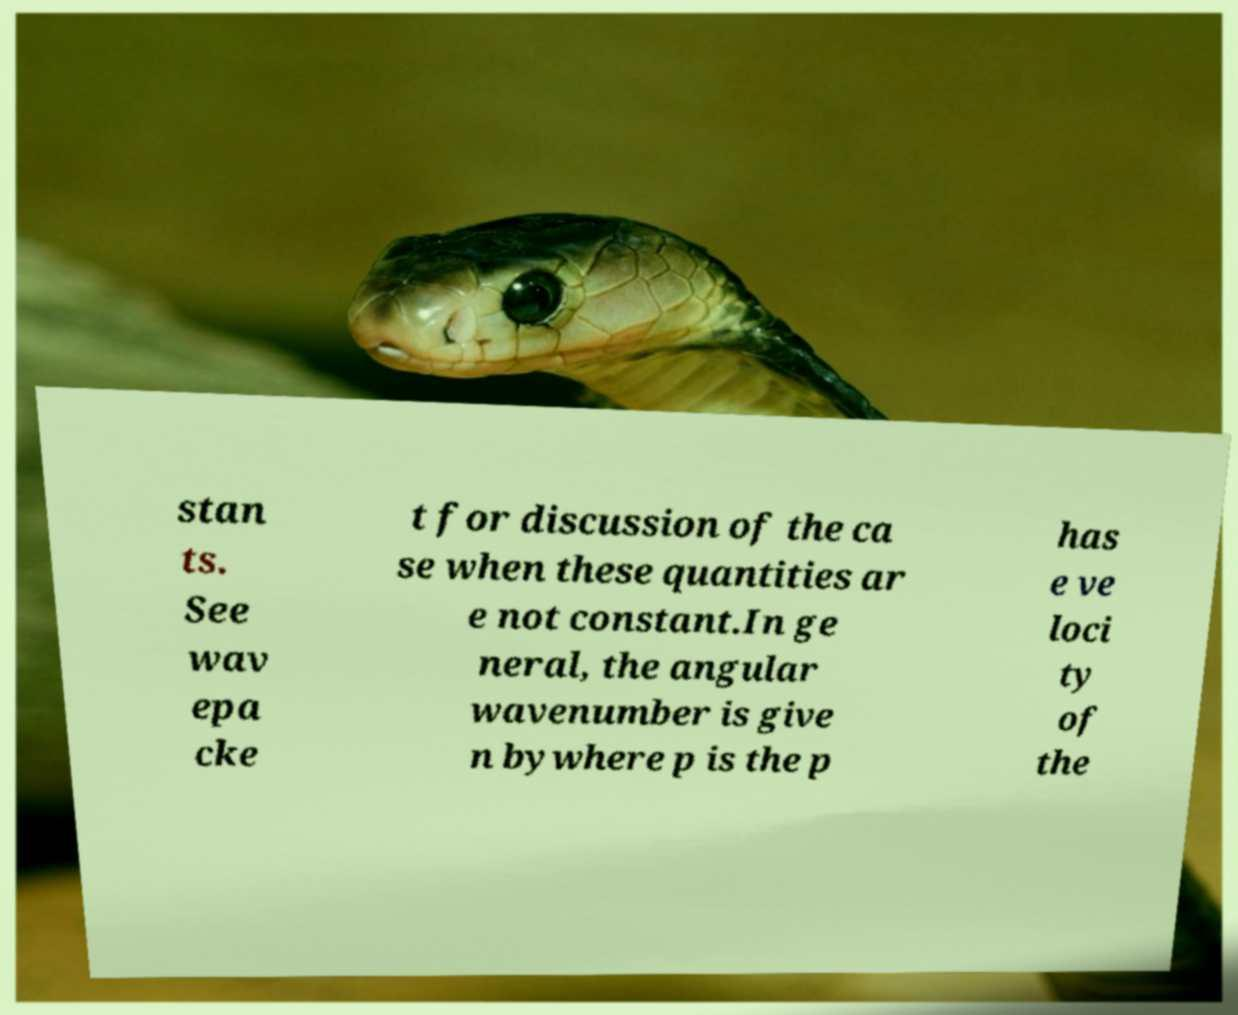I need the written content from this picture converted into text. Can you do that? stan ts. See wav epa cke t for discussion of the ca se when these quantities ar e not constant.In ge neral, the angular wavenumber is give n bywhere p is the p has e ve loci ty of the 